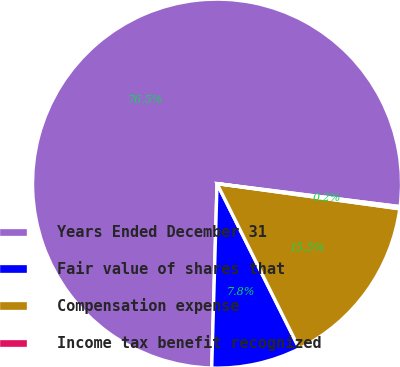<chart> <loc_0><loc_0><loc_500><loc_500><pie_chart><fcel>Years Ended December 31<fcel>Fair value of shares that<fcel>Compensation expense<fcel>Income tax benefit recognized<nl><fcel>76.53%<fcel>7.82%<fcel>15.46%<fcel>0.19%<nl></chart> 